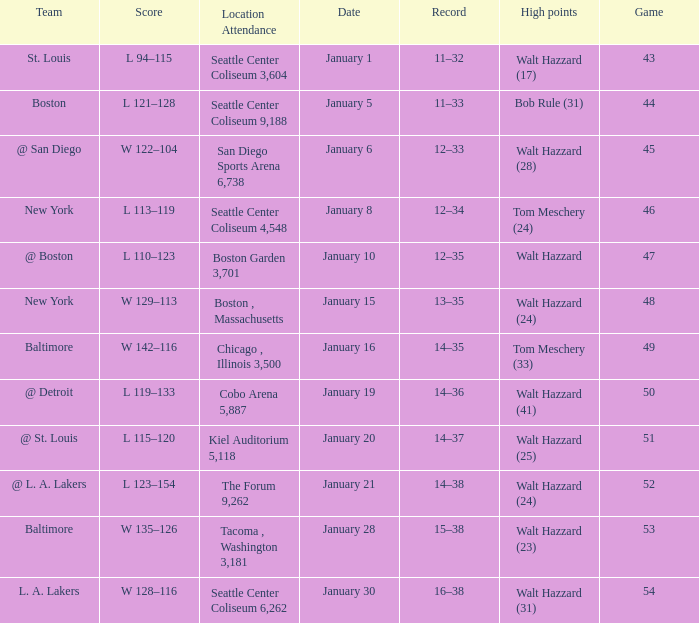What is the record for the St. Louis team? 11–32. Would you be able to parse every entry in this table? {'header': ['Team', 'Score', 'Location Attendance', 'Date', 'Record', 'High points', 'Game'], 'rows': [['St. Louis', 'L 94–115', 'Seattle Center Coliseum 3,604', 'January 1', '11–32', 'Walt Hazzard (17)', '43'], ['Boston', 'L 121–128', 'Seattle Center Coliseum 9,188', 'January 5', '11–33', 'Bob Rule (31)', '44'], ['@ San Diego', 'W 122–104', 'San Diego Sports Arena 6,738', 'January 6', '12–33', 'Walt Hazzard (28)', '45'], ['New York', 'L 113–119', 'Seattle Center Coliseum 4,548', 'January 8', '12–34', 'Tom Meschery (24)', '46'], ['@ Boston', 'L 110–123', 'Boston Garden 3,701', 'January 10', '12–35', 'Walt Hazzard', '47'], ['New York', 'W 129–113', 'Boston , Massachusetts', 'January 15', '13–35', 'Walt Hazzard (24)', '48'], ['Baltimore', 'W 142–116', 'Chicago , Illinois 3,500', 'January 16', '14–35', 'Tom Meschery (33)', '49'], ['@ Detroit', 'L 119–133', 'Cobo Arena 5,887', 'January 19', '14–36', 'Walt Hazzard (41)', '50'], ['@ St. Louis', 'L 115–120', 'Kiel Auditorium 5,118', 'January 20', '14–37', 'Walt Hazzard (25)', '51'], ['@ L. A. Lakers', 'L 123–154', 'The Forum 9,262', 'January 21', '14–38', 'Walt Hazzard (24)', '52'], ['Baltimore', 'W 135–126', 'Tacoma , Washington 3,181', 'January 28', '15–38', 'Walt Hazzard (23)', '53'], ['L. A. Lakers', 'W 128–116', 'Seattle Center Coliseum 6,262', 'January 30', '16–38', 'Walt Hazzard (31)', '54']]} 